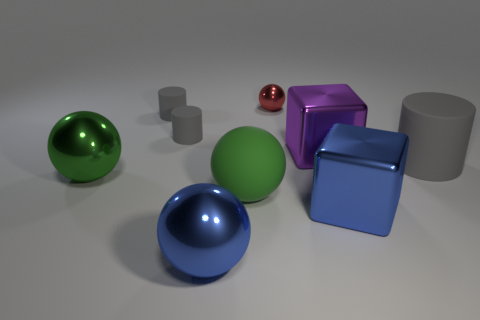Subtract all gray cylinders. How many were subtracted if there are1gray cylinders left? 2 Add 1 tiny objects. How many objects exist? 10 Subtract all cubes. How many objects are left? 7 Subtract 0 cyan spheres. How many objects are left? 9 Subtract all small red shiny things. Subtract all green metal objects. How many objects are left? 7 Add 7 large gray rubber objects. How many large gray rubber objects are left? 8 Add 5 large blue spheres. How many large blue spheres exist? 6 